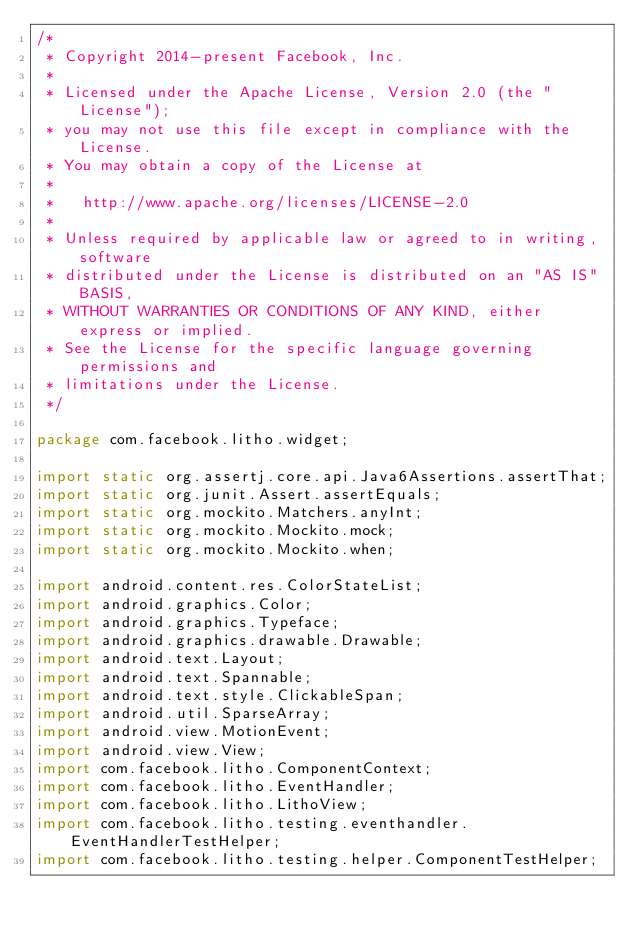<code> <loc_0><loc_0><loc_500><loc_500><_Java_>/*
 * Copyright 2014-present Facebook, Inc.
 *
 * Licensed under the Apache License, Version 2.0 (the "License");
 * you may not use this file except in compliance with the License.
 * You may obtain a copy of the License at
 *
 *   http://www.apache.org/licenses/LICENSE-2.0
 *
 * Unless required by applicable law or agreed to in writing, software
 * distributed under the License is distributed on an "AS IS" BASIS,
 * WITHOUT WARRANTIES OR CONDITIONS OF ANY KIND, either express or implied.
 * See the License for the specific language governing permissions and
 * limitations under the License.
 */

package com.facebook.litho.widget;

import static org.assertj.core.api.Java6Assertions.assertThat;
import static org.junit.Assert.assertEquals;
import static org.mockito.Matchers.anyInt;
import static org.mockito.Mockito.mock;
import static org.mockito.Mockito.when;

import android.content.res.ColorStateList;
import android.graphics.Color;
import android.graphics.Typeface;
import android.graphics.drawable.Drawable;
import android.text.Layout;
import android.text.Spannable;
import android.text.style.ClickableSpan;
import android.util.SparseArray;
import android.view.MotionEvent;
import android.view.View;
import com.facebook.litho.ComponentContext;
import com.facebook.litho.EventHandler;
import com.facebook.litho.LithoView;
import com.facebook.litho.testing.eventhandler.EventHandlerTestHelper;
import com.facebook.litho.testing.helper.ComponentTestHelper;</code> 